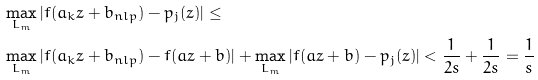Convert formula to latex. <formula><loc_0><loc_0><loc_500><loc_500>& \max _ { L _ { m } } | f ( a _ { k } z + b _ { n l p } ) - p _ { j } ( z ) | \leq \\ & \max _ { L _ { m } } | f ( a _ { k } z + b _ { n l p } ) - f ( a z + b ) | + \max _ { L _ { m } } | f ( a z + b ) - p _ { j } ( z ) | < \frac { 1 } { 2 s } + \frac { 1 } { 2 s } = \frac { 1 } { s }</formula> 